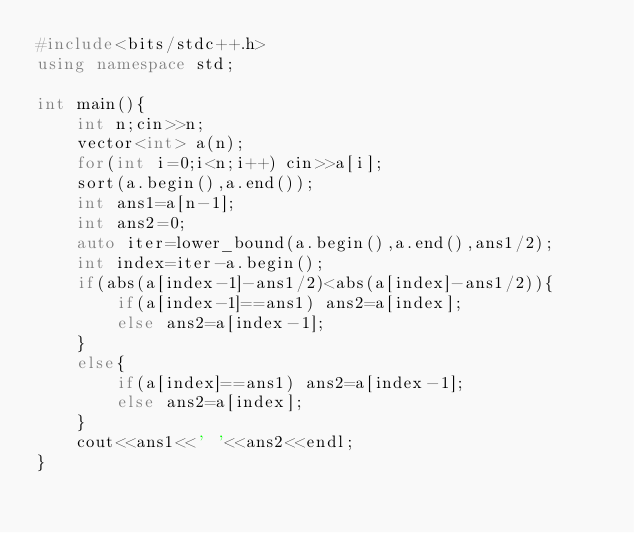Convert code to text. <code><loc_0><loc_0><loc_500><loc_500><_C++_>#include<bits/stdc++.h>
using namespace std;

int main(){
    int n;cin>>n;
    vector<int> a(n);
    for(int i=0;i<n;i++) cin>>a[i];
    sort(a.begin(),a.end());
    int ans1=a[n-1];
    int ans2=0;
    auto iter=lower_bound(a.begin(),a.end(),ans1/2);
    int index=iter-a.begin();
    if(abs(a[index-1]-ans1/2)<abs(a[index]-ans1/2)){
        if(a[index-1]==ans1) ans2=a[index];
        else ans2=a[index-1];
    }
    else{
        if(a[index]==ans1) ans2=a[index-1];
        else ans2=a[index];
    }
    cout<<ans1<<' '<<ans2<<endl;
}</code> 